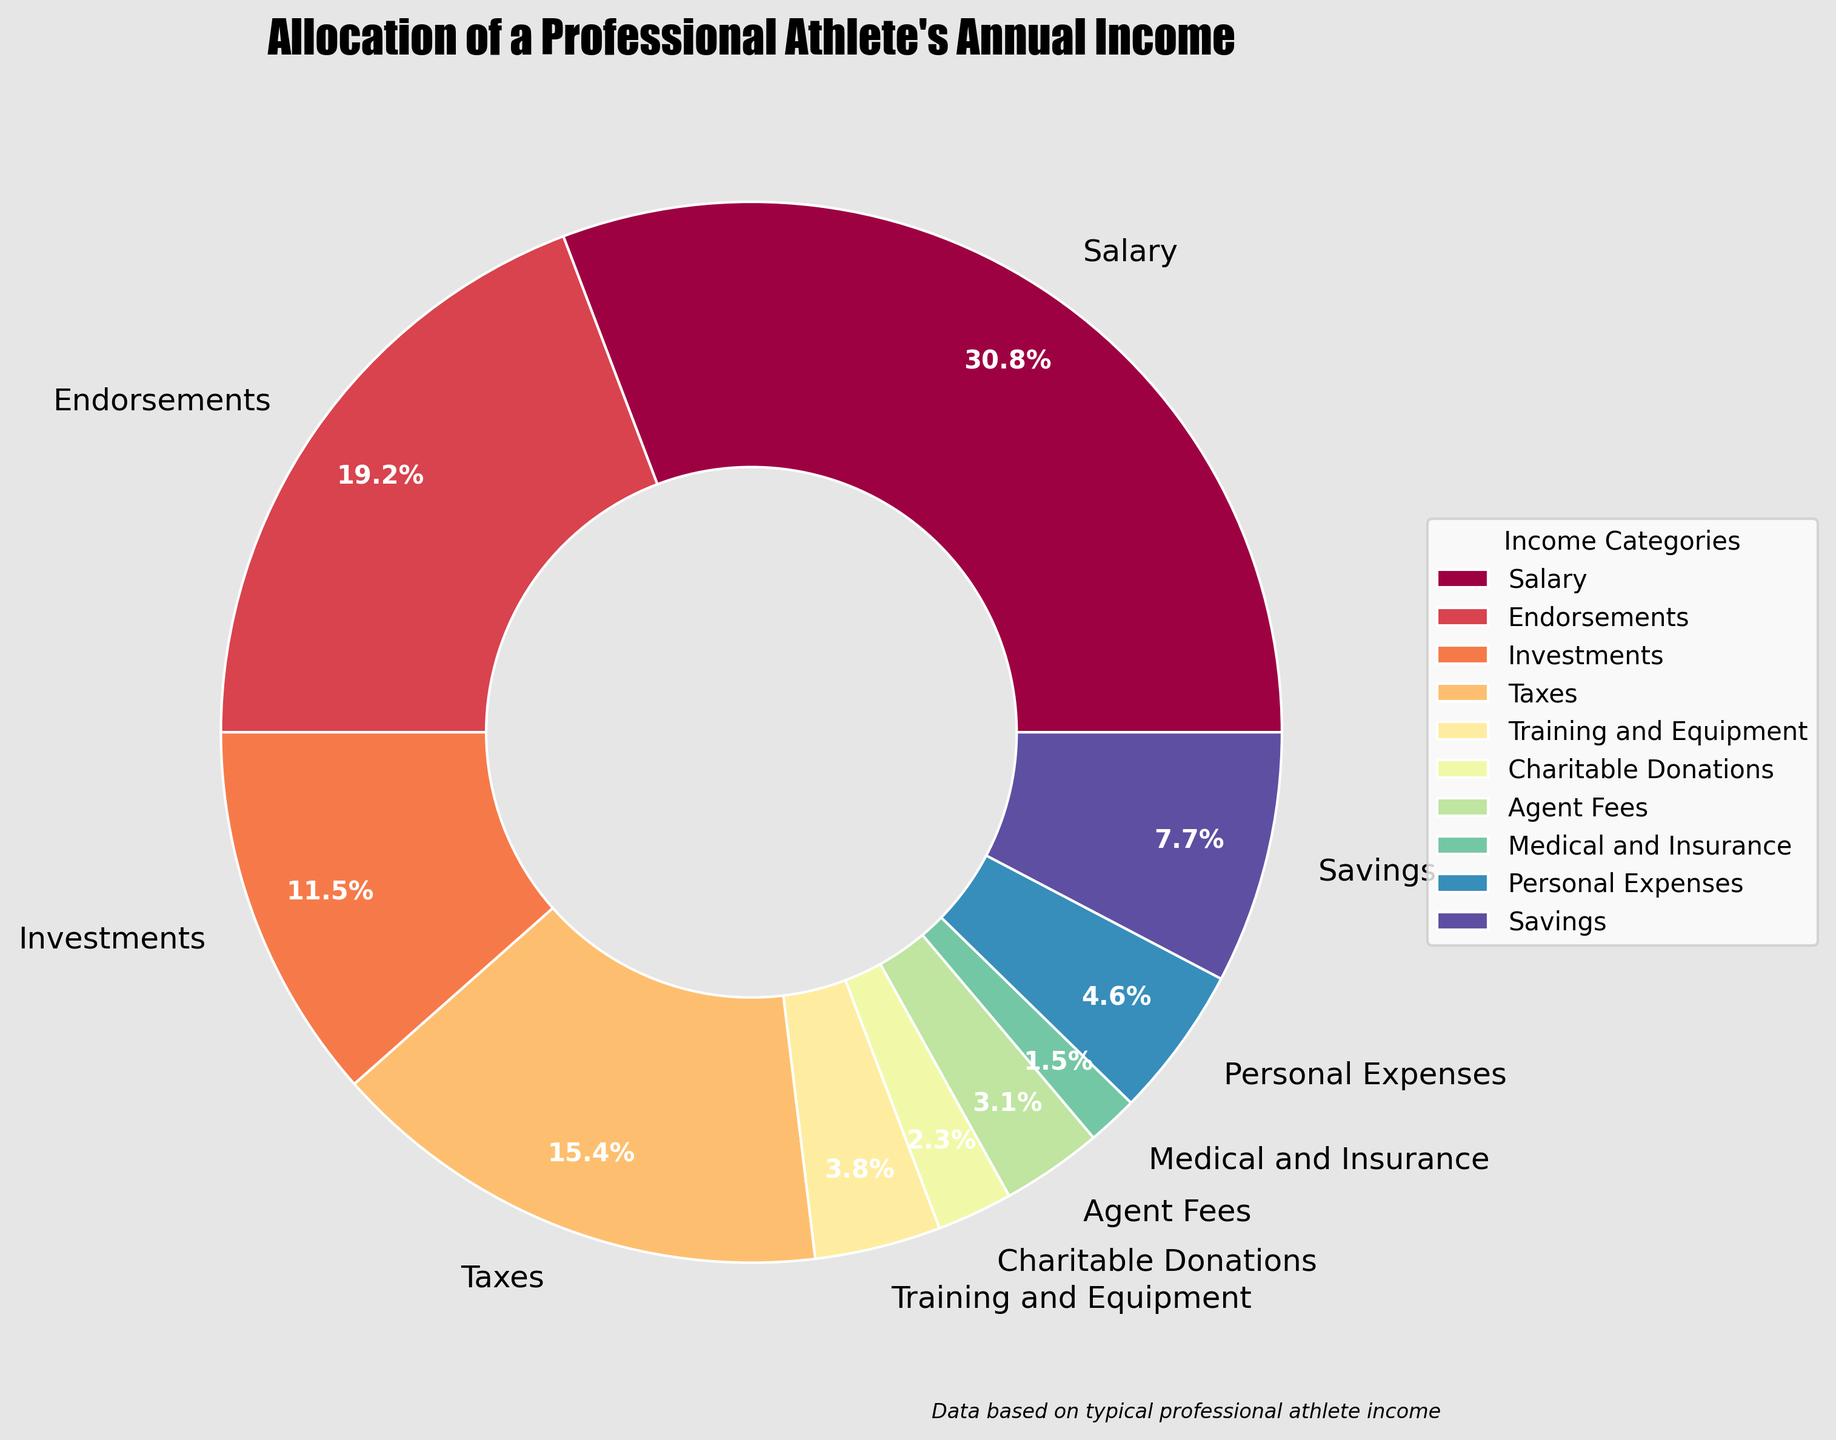Which category has the highest percentage allocation? From the pie chart, the slice labeled "Salary" has the largest portion.
Answer: Salary Which category's percentage is exactly 6%? By inspecting the pie chart, "Personal Expenses" is labeled with 6%.
Answer: Personal Expenses What is the total percentage of income allocated to Endorsements and Investments combined? Adding the percentages for Endorsements (25%) and Investments (15%): 25 + 15 = 40%
Answer: 40% How much greater is the percentage allocated to Salary compared to Endorsements? Subtract the percentage of Endorsements (25%) from Salary (40%): 40 - 25 = 15%
Answer: 15% What is the difference in percentage allocation between Taxes and Medical and Insurance? Subtract the percentage of Medical and Insurance (2%) from Taxes (20%): 20 - 2 = 18%
Answer: 18% Which category has the smallest percentage allocation? The smallest portion in the pie chart is labeled "Medical and Insurance" with 2%.
Answer: Medical and Insurance How does the percentage for Training and Equipment compare to the percentage for Agent Fees? Training and Equipment has 5%, whereas Agent Fees have 4%. 5% is greater than 4%
Answer: Training and Equipment > Agent Fees Is the percentage allocated to Charitable Donations greater than that allocated to Medical and Insurance? The chart shows Charitable Donations at 3% and Medical and Insurance at 2%. 3% is greater than 2%.
Answer: Yes How many categories have a percentage allocation less than 10%? Categories with less than 10% are Training and Equipment (5%), Charitable Donations (3%), Agent Fees (4%), Medical and Insurance (2%), and Personal Expenses (6%). There are five such categories.
Answer: 5 If you sum up the percentages for Salary, Endorsements, and Taxes, what do you get? Adding the percentages for Salary (40%), Endorsements (25%), and Taxes (20%): 40 + 25 + 20 = 85%
Answer: 85% 